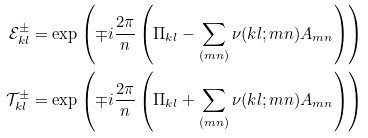<formula> <loc_0><loc_0><loc_500><loc_500>\mathcal { E } _ { k l } ^ { \pm } & = \exp \left ( \mp i \frac { 2 \pi } { n } \left ( \Pi _ { k l } - \sum _ { ( m n ) } \nu ( k l ; m n ) A _ { m n } \right ) \right ) \\ \mathcal { T } _ { k l } ^ { \pm } & = \exp \left ( \mp i \frac { 2 \pi } { n } \left ( \Pi _ { k l } + \sum _ { ( m n ) } \nu ( k l ; m n ) A _ { m n } \right ) \right )</formula> 